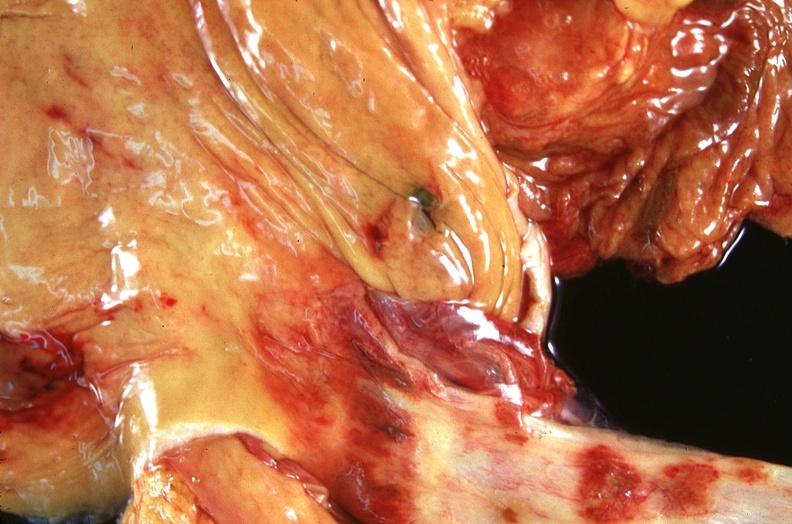does this image show stomach and esophagus, ulcers?
Answer the question using a single word or phrase. Yes 